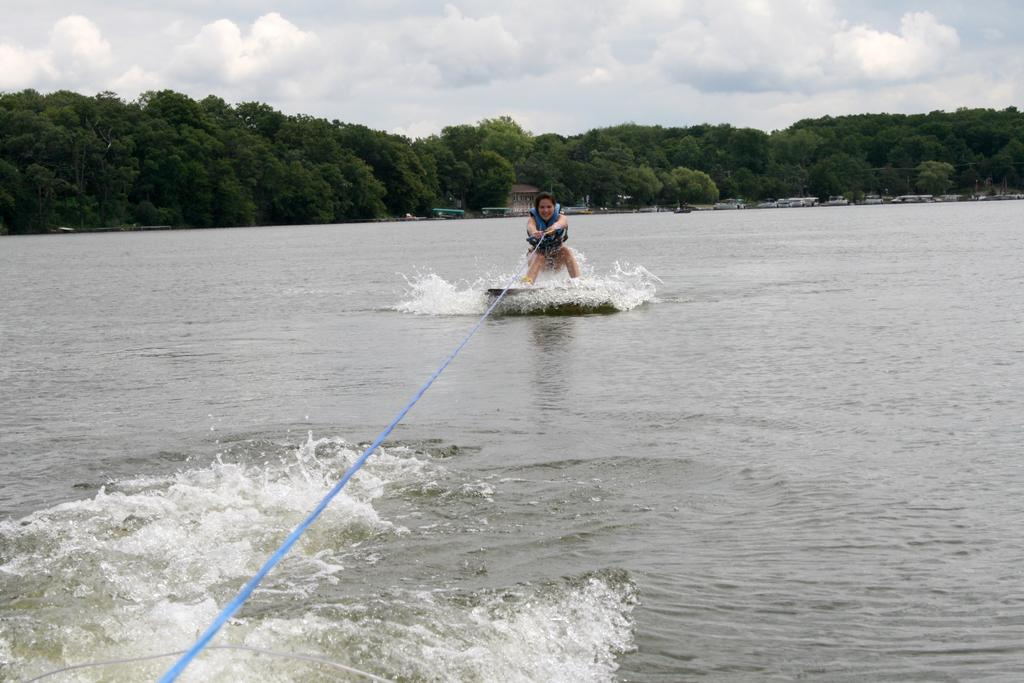What activity is the person in the image engaged in? The person in the image is doing water skiing. What can be seen in the background of the image? There are boats and a group of trees in the background of the image. What is visible at the top of the image? The sky is visible at the top of the image. What type of drink is the person holding while attempting to reach the moon in the image? There is no person holding a drink or attempting to reach the moon in the image; it features a person doing water skiing. 